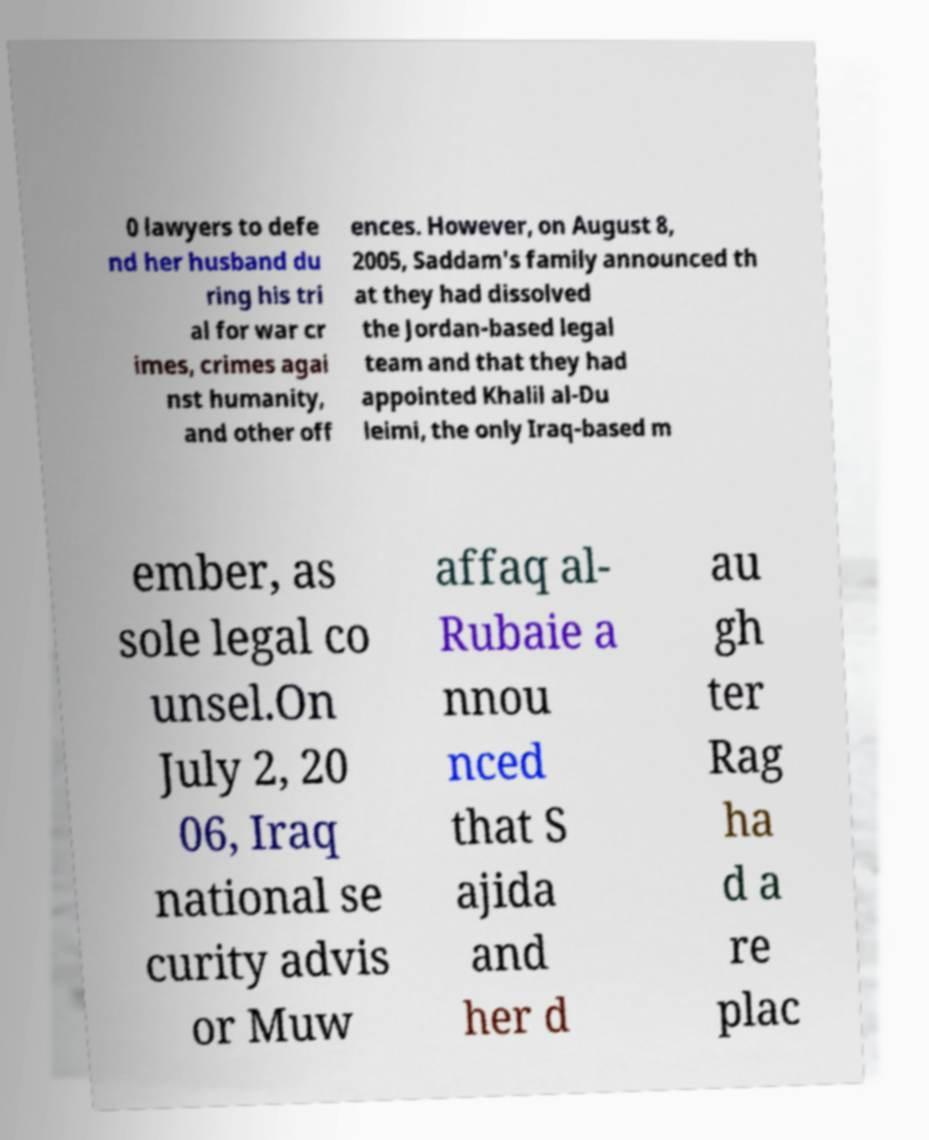Can you read and provide the text displayed in the image?This photo seems to have some interesting text. Can you extract and type it out for me? 0 lawyers to defe nd her husband du ring his tri al for war cr imes, crimes agai nst humanity, and other off ences. However, on August 8, 2005, Saddam's family announced th at they had dissolved the Jordan-based legal team and that they had appointed Khalil al-Du leimi, the only Iraq-based m ember, as sole legal co unsel.On July 2, 20 06, Iraq national se curity advis or Muw affaq al- Rubaie a nnou nced that S ajida and her d au gh ter Rag ha d a re plac 